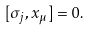<formula> <loc_0><loc_0><loc_500><loc_500>[ \sigma _ { j } , x _ { \mu } ] = 0 .</formula> 